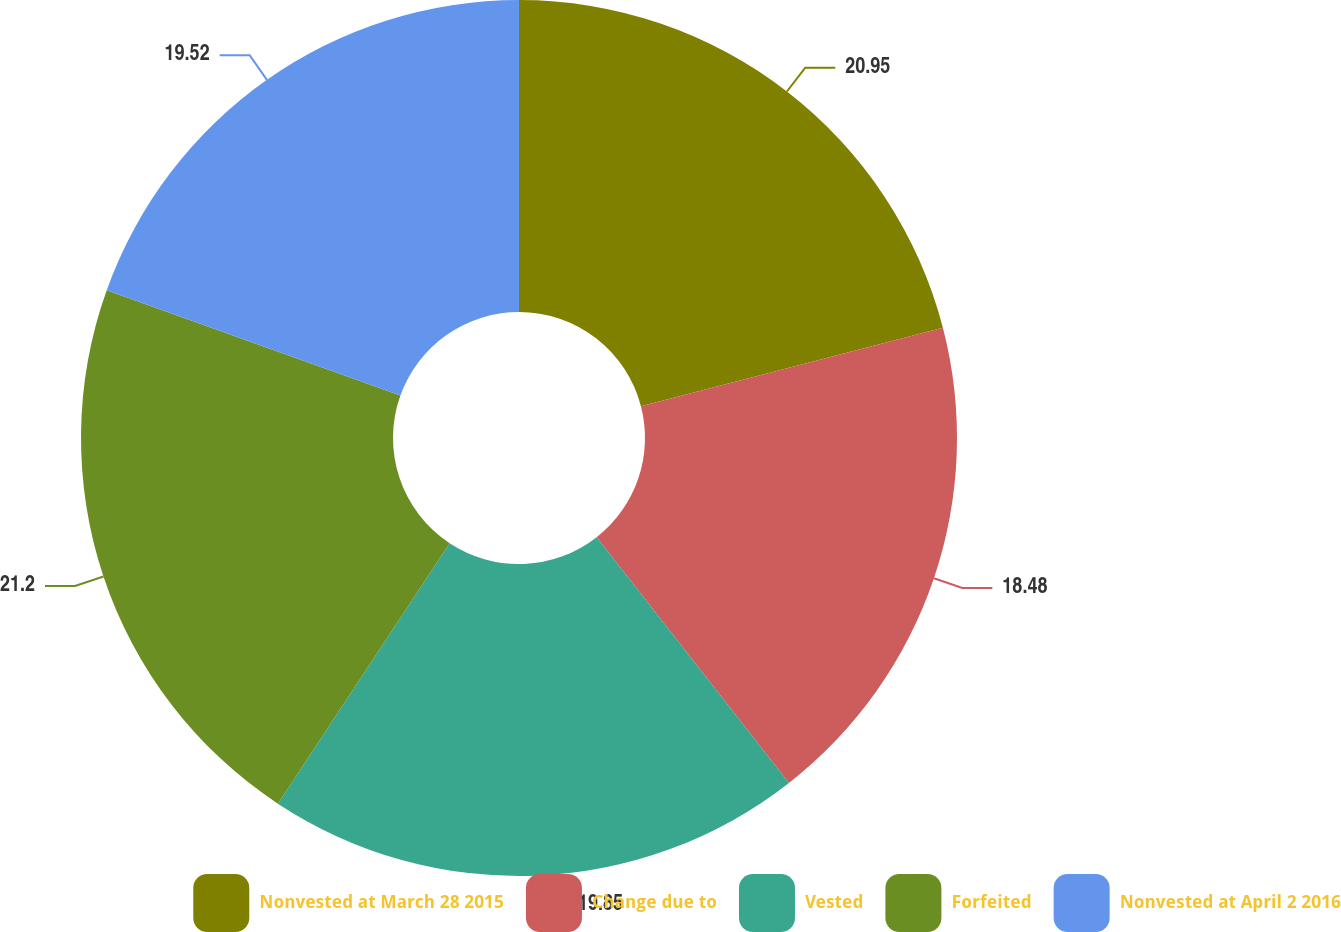<chart> <loc_0><loc_0><loc_500><loc_500><pie_chart><fcel>Nonvested at March 28 2015<fcel>Change due to<fcel>Vested<fcel>Forfeited<fcel>Nonvested at April 2 2016<nl><fcel>20.95%<fcel>18.48%<fcel>19.85%<fcel>21.2%<fcel>19.52%<nl></chart> 